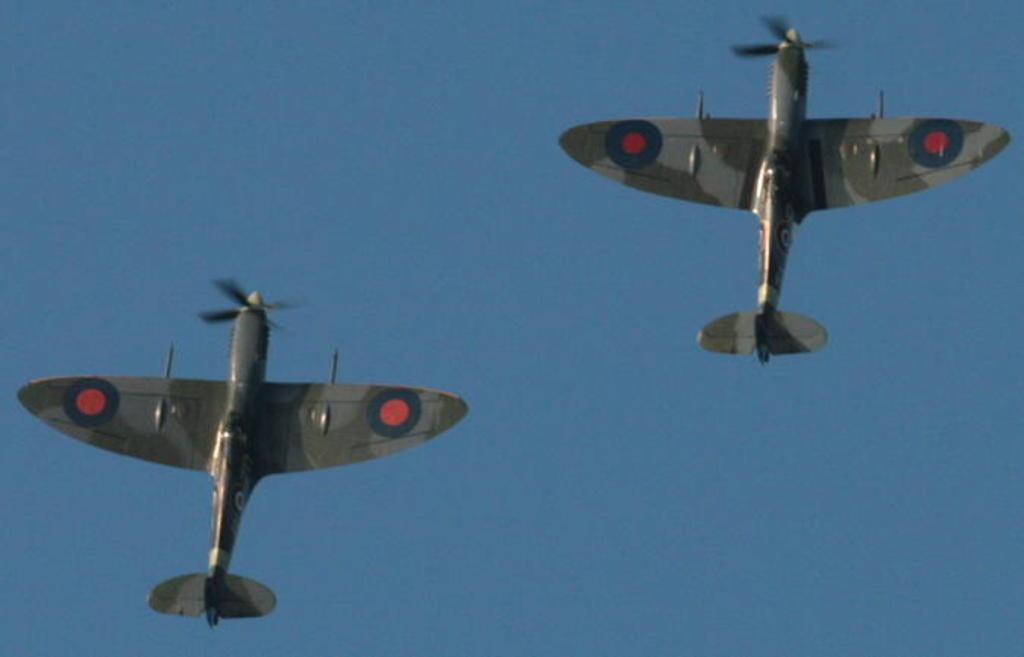How many airplanes are visible in the image? There are two airplanes in the image. What are the airplanes doing in the image? The airplanes are flying in the sky. Where is the plastic shop located in the image? There is no plastic shop present in the image; it only features two airplanes flying in the sky. 